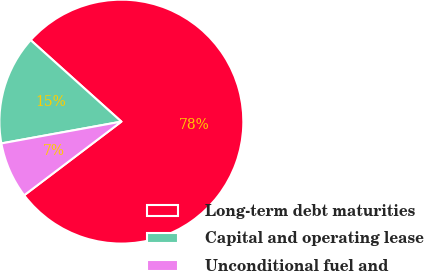<chart> <loc_0><loc_0><loc_500><loc_500><pie_chart><fcel>Long-term debt maturities<fcel>Capital and operating lease<fcel>Unconditional fuel and<nl><fcel>78.03%<fcel>14.51%<fcel>7.46%<nl></chart> 